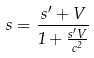Convert formula to latex. <formula><loc_0><loc_0><loc_500><loc_500>s = \frac { s ^ { \prime } + V } { 1 + \frac { s ^ { \prime } V } { c ^ { 2 } } }</formula> 